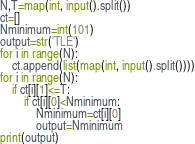<code> <loc_0><loc_0><loc_500><loc_500><_Python_>N,T=map(int, input().split())
ct=[]
Nminimum=int(101)
output=str('TLE')
for i in range(N):
    ct.append(list(map(int, input().split())))
for i in range(N):
    if ct[i][1]<=T:
        if ct[i][0]<Nminimum:
            Nminimum=ct[i][0]
            output=Nminimum
print(output)</code> 